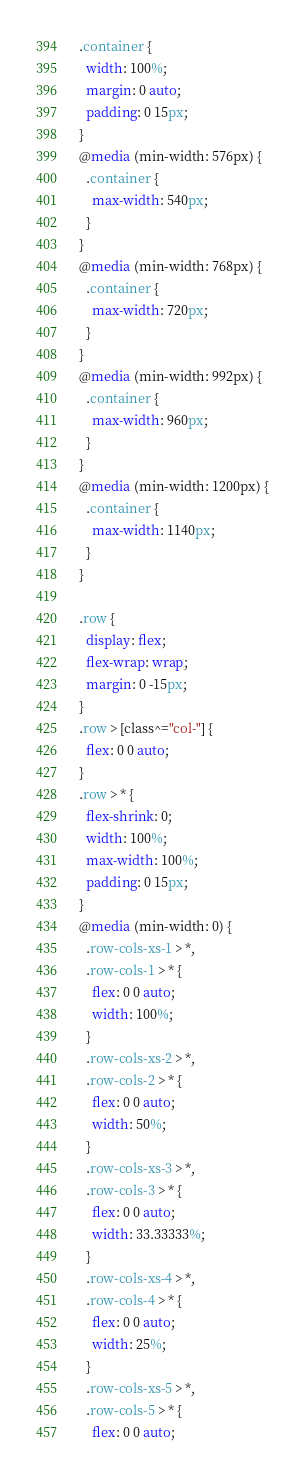<code> <loc_0><loc_0><loc_500><loc_500><_CSS_>.container {
  width: 100%;
  margin: 0 auto;
  padding: 0 15px;
}
@media (min-width: 576px) {
  .container {
    max-width: 540px;
  }
}
@media (min-width: 768px) {
  .container {
    max-width: 720px;
  }
}
@media (min-width: 992px) {
  .container {
    max-width: 960px;
  }
}
@media (min-width: 1200px) {
  .container {
    max-width: 1140px;
  }
}

.row {
  display: flex;
  flex-wrap: wrap;
  margin: 0 -15px;
}
.row > [class^="col-"] {
  flex: 0 0 auto;
}
.row > * {
  flex-shrink: 0;
  width: 100%;
  max-width: 100%;
  padding: 0 15px;
}
@media (min-width: 0) {
  .row-cols-xs-1 > *,
  .row-cols-1 > * {
    flex: 0 0 auto;
    width: 100%;
  }
  .row-cols-xs-2 > *,
  .row-cols-2 > * {
    flex: 0 0 auto;
    width: 50%;
  }
  .row-cols-xs-3 > *,
  .row-cols-3 > * {
    flex: 0 0 auto;
    width: 33.33333%;
  }
  .row-cols-xs-4 > *,
  .row-cols-4 > * {
    flex: 0 0 auto;
    width: 25%;
  }
  .row-cols-xs-5 > *,
  .row-cols-5 > * {
    flex: 0 0 auto;</code> 